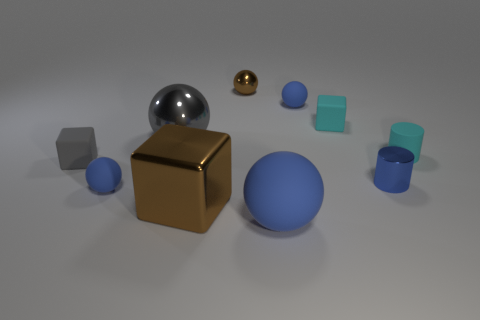How many balls are either big matte things or large brown objects?
Your answer should be compact. 1. The cyan block has what size?
Provide a short and direct response. Small. How many rubber cylinders are in front of the metal block?
Offer a very short reply. 0. There is a cyan rubber thing right of the blue cylinder in front of the tiny gray object; how big is it?
Offer a terse response. Small. There is a gray rubber thing behind the large blue matte ball; is it the same shape as the blue rubber thing on the left side of the large cube?
Keep it short and to the point. No. There is a small blue rubber thing to the right of the matte ball on the left side of the big brown object; what is its shape?
Your answer should be compact. Sphere. There is a object that is on the left side of the big rubber ball and behind the cyan rubber cube; how big is it?
Your answer should be compact. Small. There is a large brown object; does it have the same shape as the brown object behind the big block?
Ensure brevity in your answer.  No. There is a matte object that is the same shape as the small blue shiny thing; what size is it?
Make the answer very short. Small. Is the color of the large cube the same as the tiny metallic thing behind the small metallic cylinder?
Offer a very short reply. Yes. 